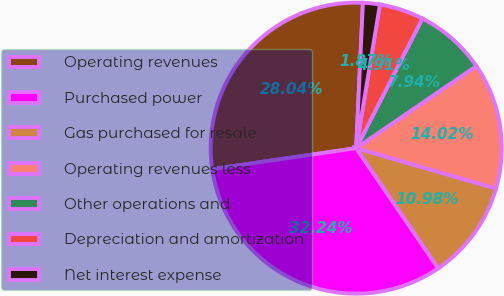<chart> <loc_0><loc_0><loc_500><loc_500><pie_chart><fcel>Operating revenues<fcel>Purchased power<fcel>Gas purchased for resale<fcel>Operating revenues less<fcel>Other operations and<fcel>Depreciation and amortization<fcel>Net interest expense<nl><fcel>28.04%<fcel>32.24%<fcel>10.98%<fcel>14.02%<fcel>7.94%<fcel>4.91%<fcel>1.87%<nl></chart> 